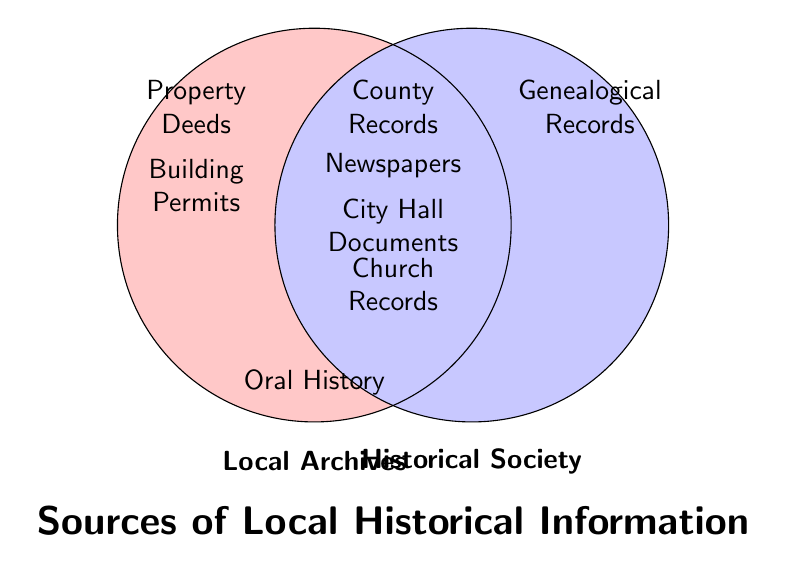Which sources are unique to Local Archives? By looking at the left circle of the diagram, the sources only inside it are unique to Local Archives. They include Property Deeds and Building Permits.
Answer: Property Deeds, Building Permits Which sources are unique to the Historical Society? By examining the right circle, the sources solely in that area are unique to the Historical Society. They include Genealogical Records.
Answer: Genealogical Records Which sources are shared between Local Archives and the Historical Society? Whatever falls within the overlapping area of the circles is shared by both. They include County Records, Newspapers, City Hall Documents, and Church Records.
Answer: County Records, Newspapers, City Hall Documents, Church Records How many sources are unique to either the Local Archives or the Historical Society? Add the number of unique sources in the left circle (2) to the unique sources in the right circle (1), making it a total of 3.
Answer: 3 Which source is represented outside the overlapping section and only inside the Local Archives circle but not in the Historical Society circle? From the left, unique part of the Local Archives circle, the sources are Property Deeds and Building Permits.
Answer: Property Deeds, Building Permits Count the number of sources in the overlapping area and unique areas for both the Local Archives and the Historical Society There are 4 sources in the overlapping area, 2 unique sources in the Local Archives, and 1 unique source in the Historical Society. So, total 4+2+1 = 7.
Answer: 7 Are there more sources shared between both or unique to Local Archives? Compare the number of shared sources (4) with the unique sources to the Local Archives (2). Since 4 is greater than 2, there are more shared sources.
Answer: More shared sources Are there any sources mentioned only in the Oral History? Find the text outside the circles under the Oral History label. If there is any, it indicates sources specific to Oral History only. The one listed is Oral History itself.
Answer: Oral History What's the color used to indicate the Local Archives circle? The left circle representing Local Archives is filled with a light red color.
Answer: Light red What's the color used to indicate the Historical Society circle? The right circle representing Historical Society is filled with a light blue color.
Answer: Light blue 